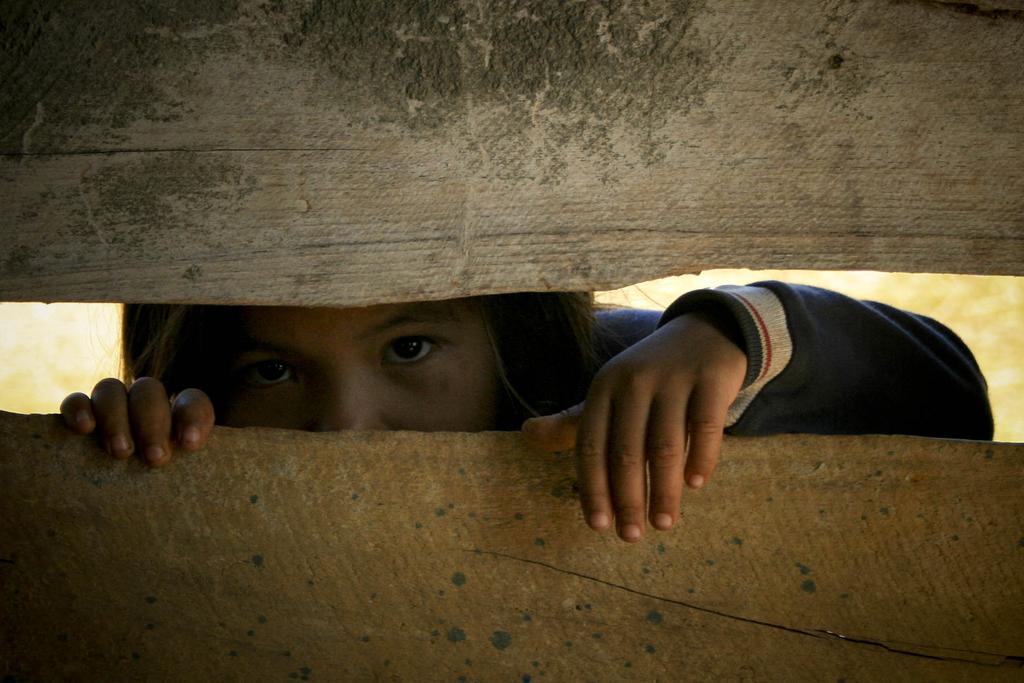In one or two sentences, can you explain what this image depicts? In this image there is a girl who is seeing from the hole which is in between the two wooden sticks. 